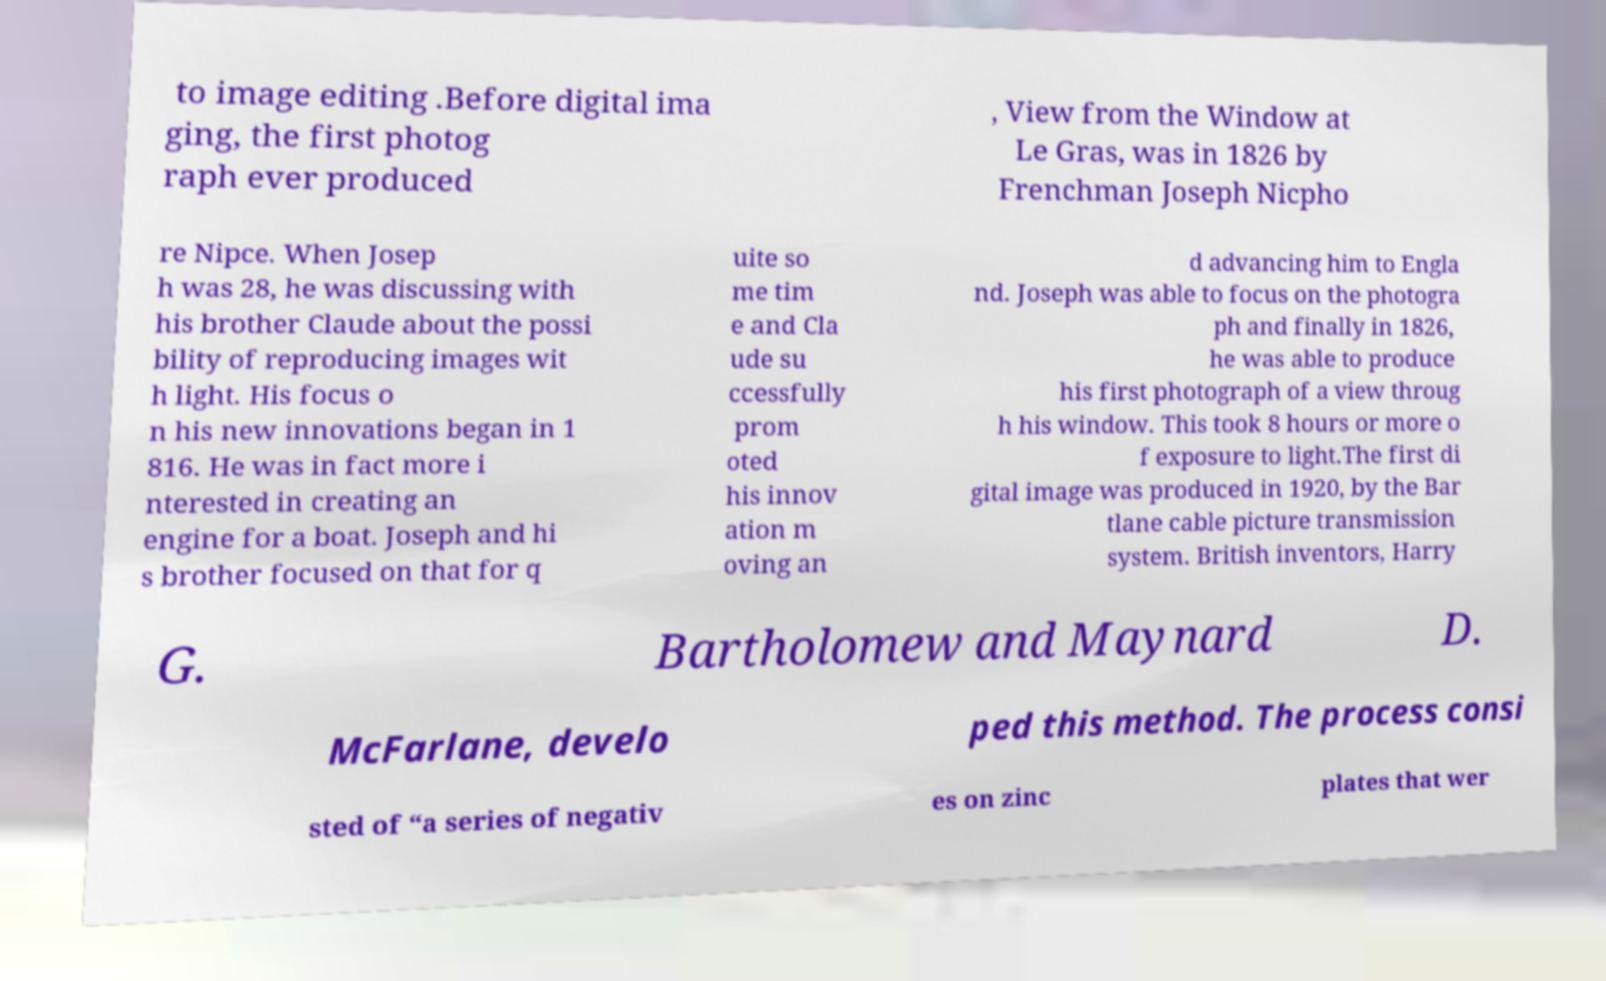Please read and relay the text visible in this image. What does it say? to image editing .Before digital ima ging, the first photog raph ever produced , View from the Window at Le Gras, was in 1826 by Frenchman Joseph Nicpho re Nipce. When Josep h was 28, he was discussing with his brother Claude about the possi bility of reproducing images wit h light. His focus o n his new innovations began in 1 816. He was in fact more i nterested in creating an engine for a boat. Joseph and hi s brother focused on that for q uite so me tim e and Cla ude su ccessfully prom oted his innov ation m oving an d advancing him to Engla nd. Joseph was able to focus on the photogra ph and finally in 1826, he was able to produce his first photograph of a view throug h his window. This took 8 hours or more o f exposure to light.The first di gital image was produced in 1920, by the Bar tlane cable picture transmission system. British inventors, Harry G. Bartholomew and Maynard D. McFarlane, develo ped this method. The process consi sted of “a series of negativ es on zinc plates that wer 